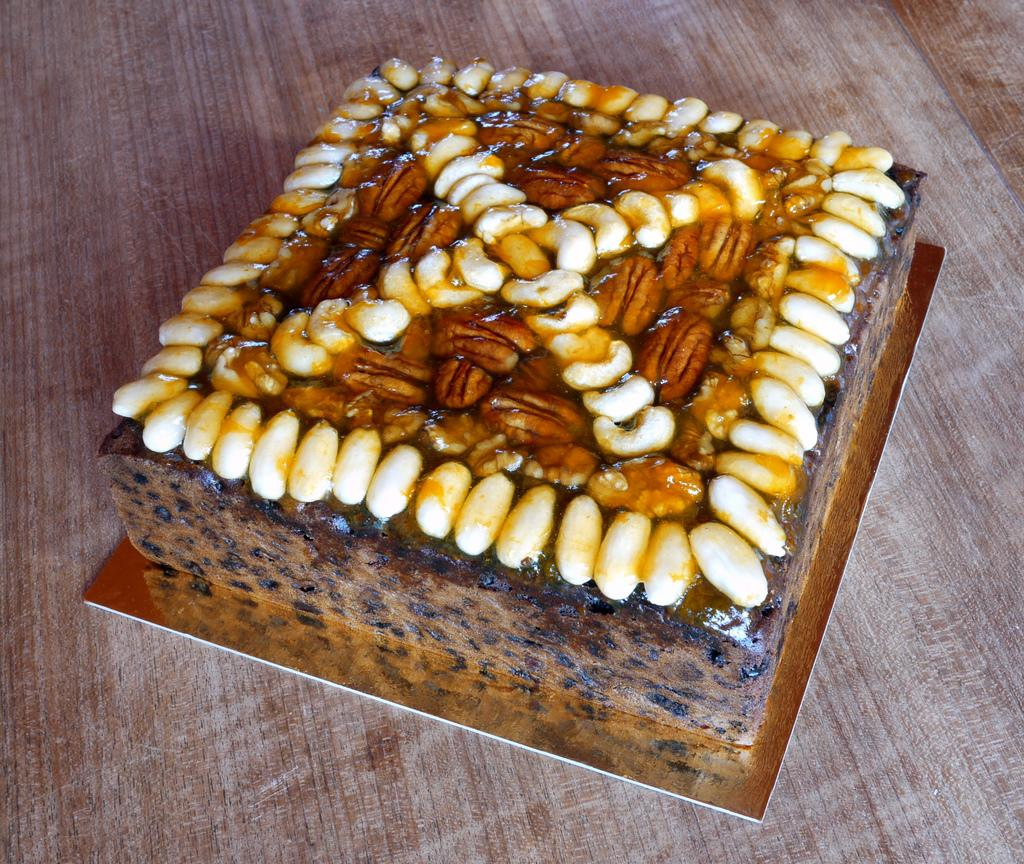What is the main subject of the image? There is a cake in the image. What decorations are on the cake? The cake has dry fruits on it. How is the cake supported or displayed? The cake is on a cake base. What type of surface is the cake placed on? The cake is on a wooden surface. Can you see any railway tracks or trains in the image? No, there are no railway tracks or trains present in the image. Is there a scarf draped over the cake in the image? No, there is no scarf present in the image. 